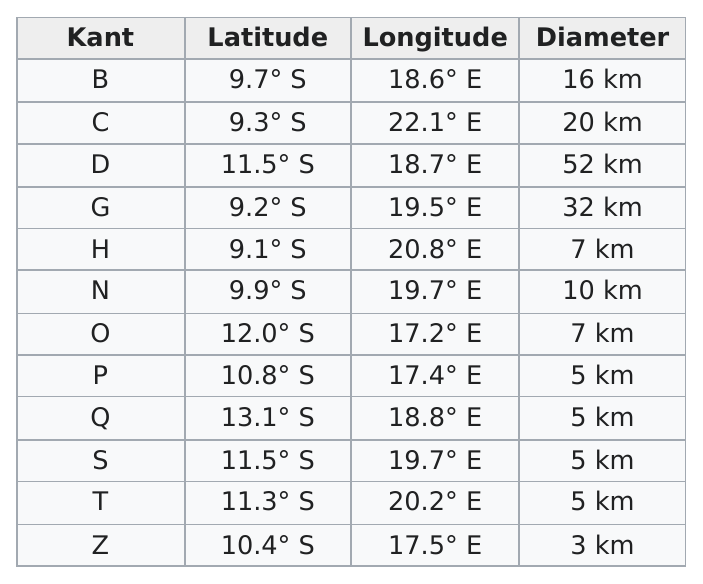Draw attention to some important aspects in this diagram. The diameter of Kant B is significantly larger than that of Kant H, which is approximately 9 kilometers. There are four Kant that have coordinates over 10.0 degrees south and over 18.0 degrees east. 